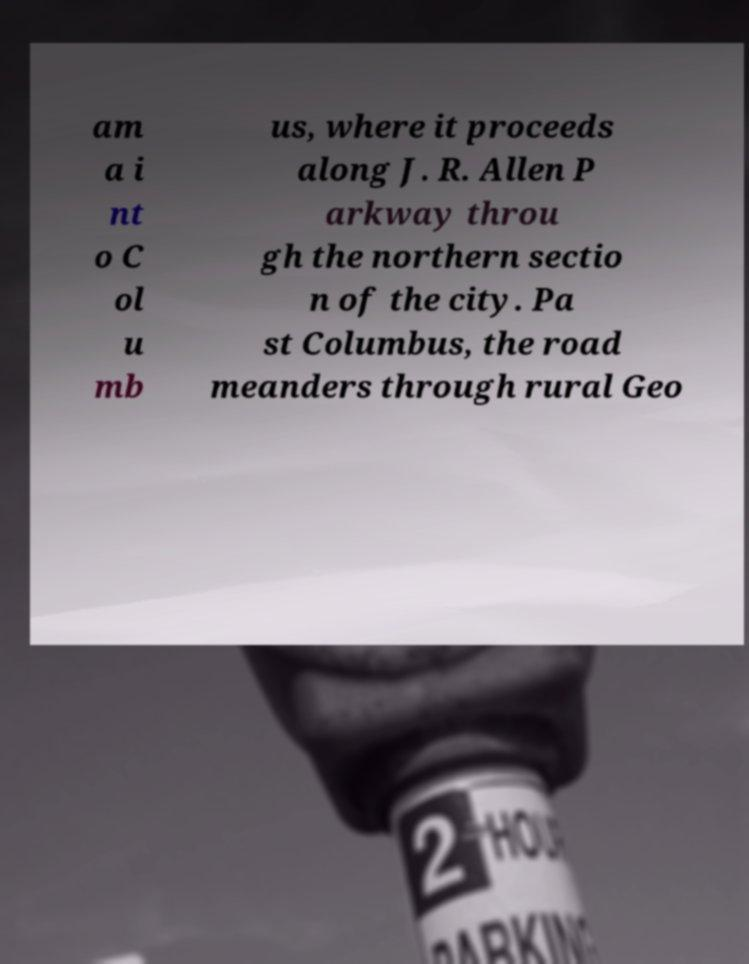Can you read and provide the text displayed in the image?This photo seems to have some interesting text. Can you extract and type it out for me? am a i nt o C ol u mb us, where it proceeds along J. R. Allen P arkway throu gh the northern sectio n of the city. Pa st Columbus, the road meanders through rural Geo 